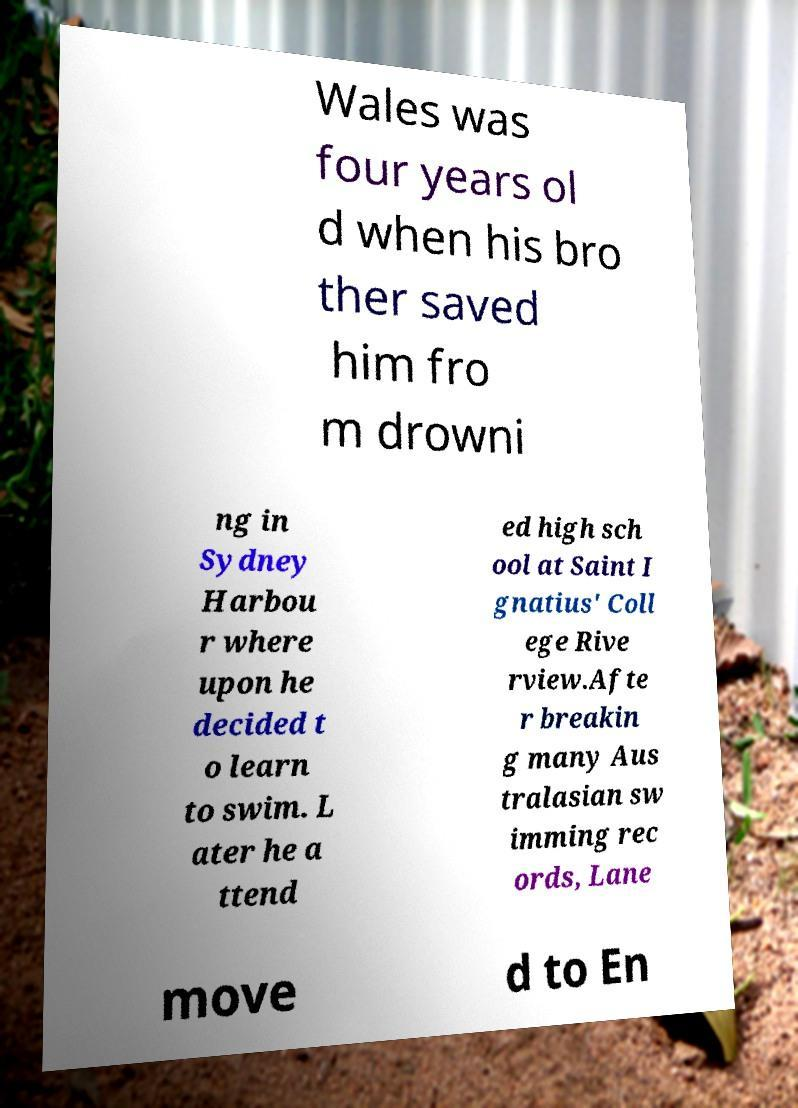There's text embedded in this image that I need extracted. Can you transcribe it verbatim? Wales was four years ol d when his bro ther saved him fro m drowni ng in Sydney Harbou r where upon he decided t o learn to swim. L ater he a ttend ed high sch ool at Saint I gnatius' Coll ege Rive rview.Afte r breakin g many Aus tralasian sw imming rec ords, Lane move d to En 